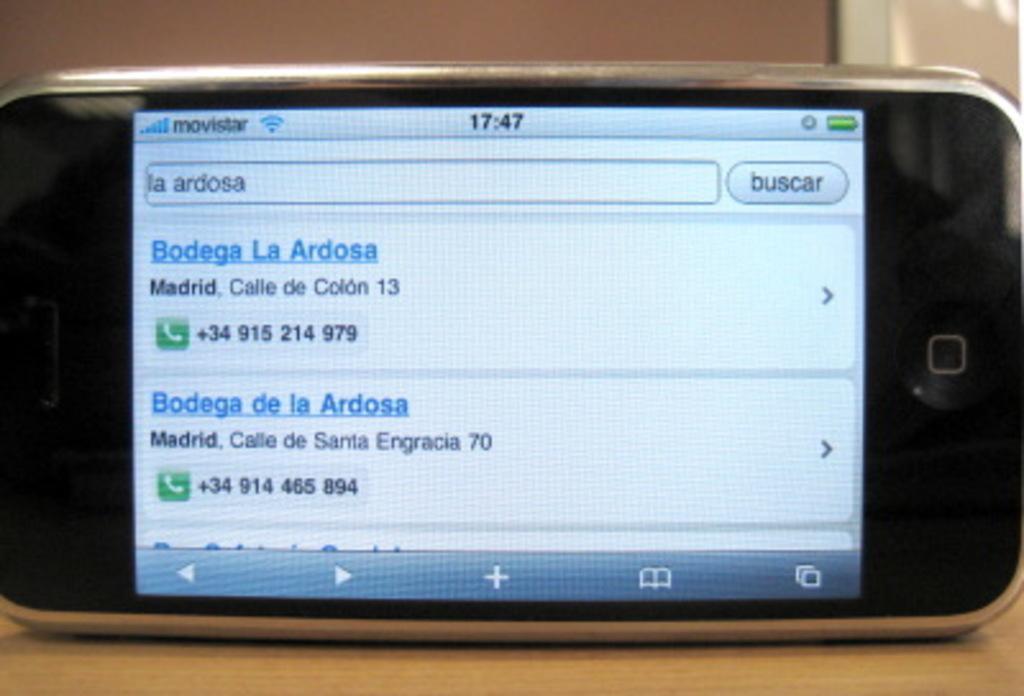Could you give a brief overview of what you see in this image? In this picture there is a cell phone on the table. On the screen there is text and there are icons. At the back it looks like a wall. 